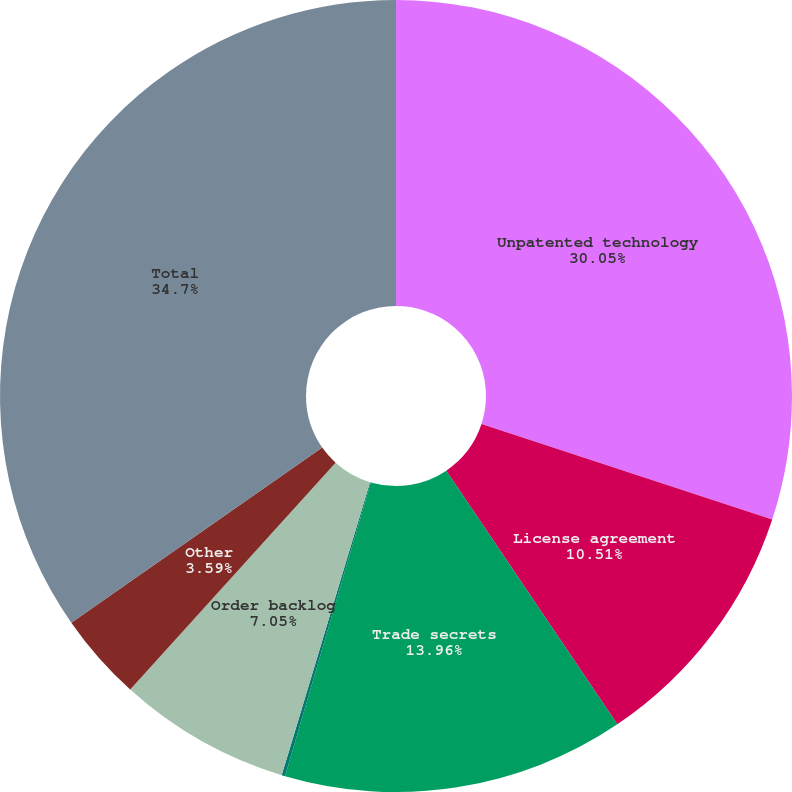<chart> <loc_0><loc_0><loc_500><loc_500><pie_chart><fcel>Unpatented technology<fcel>License agreement<fcel>Trade secrets<fcel>Patented technology<fcel>Order backlog<fcel>Other<fcel>Total<nl><fcel>30.05%<fcel>10.51%<fcel>13.96%<fcel>0.14%<fcel>7.05%<fcel>3.59%<fcel>34.7%<nl></chart> 